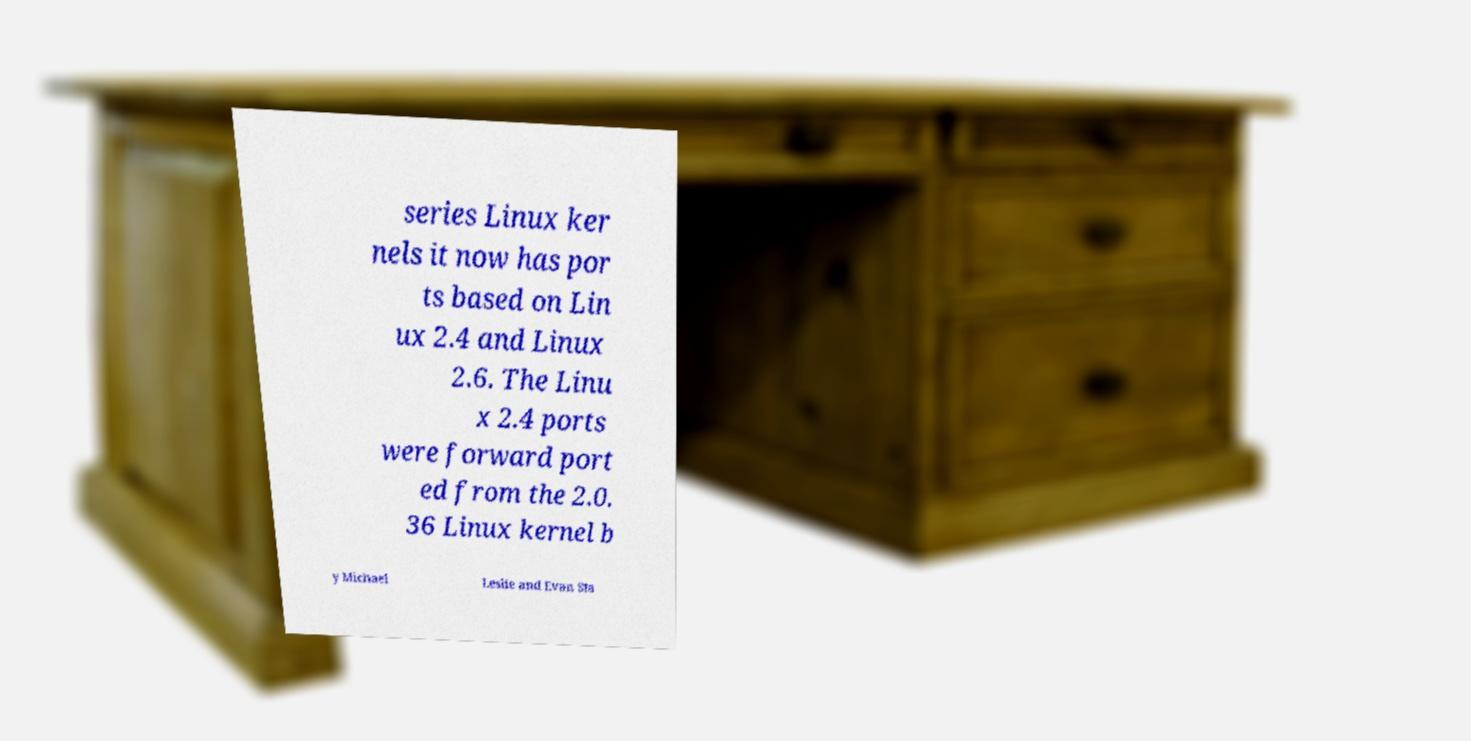Please read and relay the text visible in this image. What does it say? series Linux ker nels it now has por ts based on Lin ux 2.4 and Linux 2.6. The Linu x 2.4 ports were forward port ed from the 2.0. 36 Linux kernel b y Michael Leslie and Evan Sta 